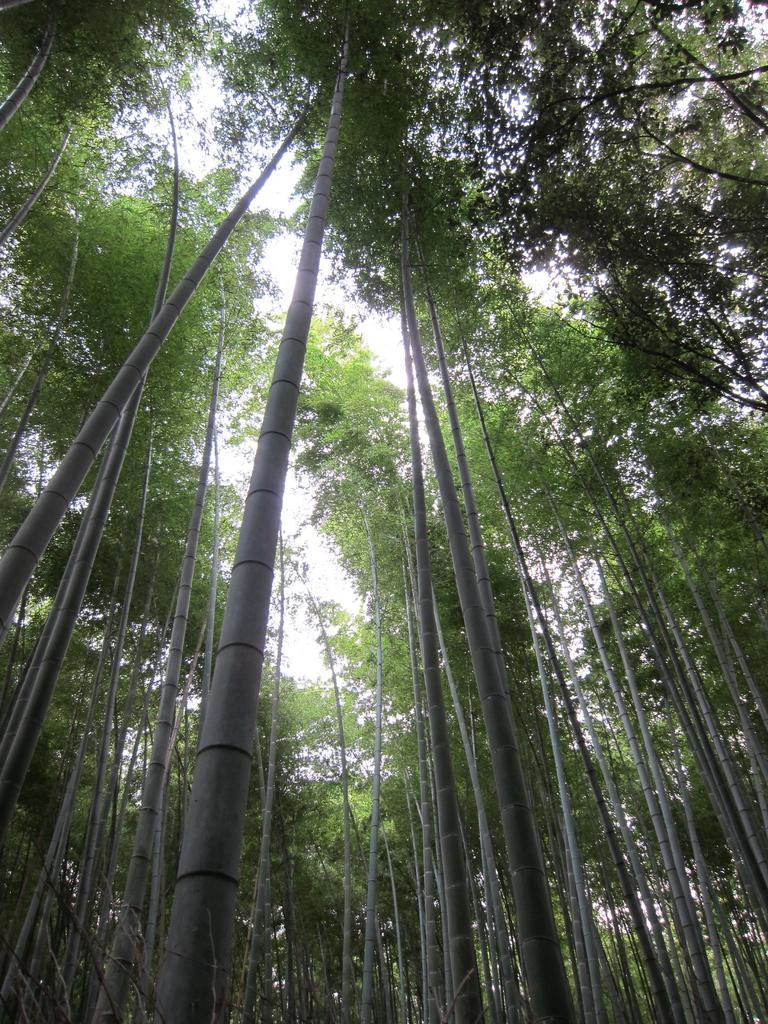What is the primary feature of the image? There are many trees in the image. Can you describe the landscape in the image? The landscape in the image is dominated by trees. Where is the basket of snails located in the image? There is no basket of snails present in the image. What type of needle can be seen being used by the trees in the image? There are no needles present in the image, as trees do not use needles for any purpose. 